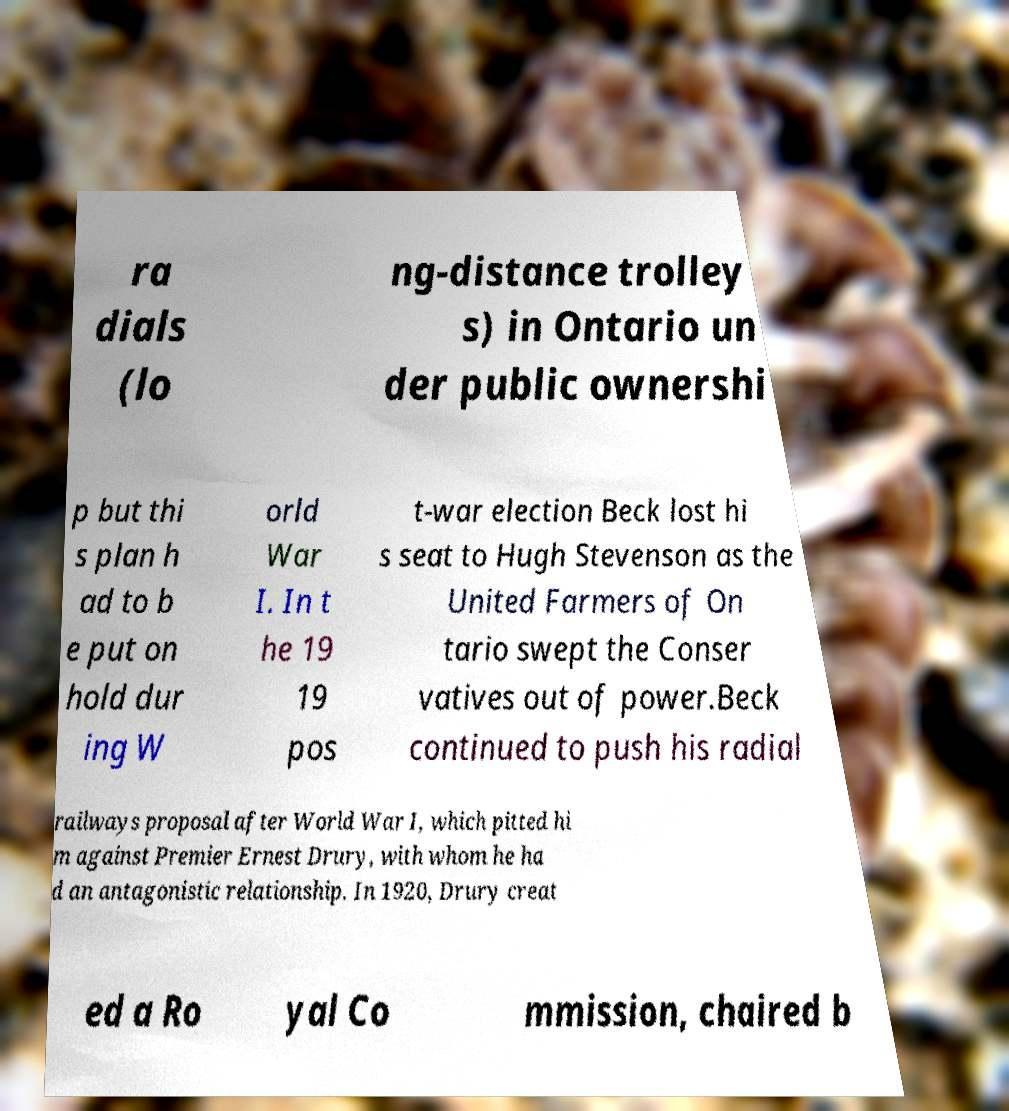What messages or text are displayed in this image? I need them in a readable, typed format. ra dials (lo ng-distance trolley s) in Ontario un der public ownershi p but thi s plan h ad to b e put on hold dur ing W orld War I. In t he 19 19 pos t-war election Beck lost hi s seat to Hugh Stevenson as the United Farmers of On tario swept the Conser vatives out of power.Beck continued to push his radial railways proposal after World War I, which pitted hi m against Premier Ernest Drury, with whom he ha d an antagonistic relationship. In 1920, Drury creat ed a Ro yal Co mmission, chaired b 